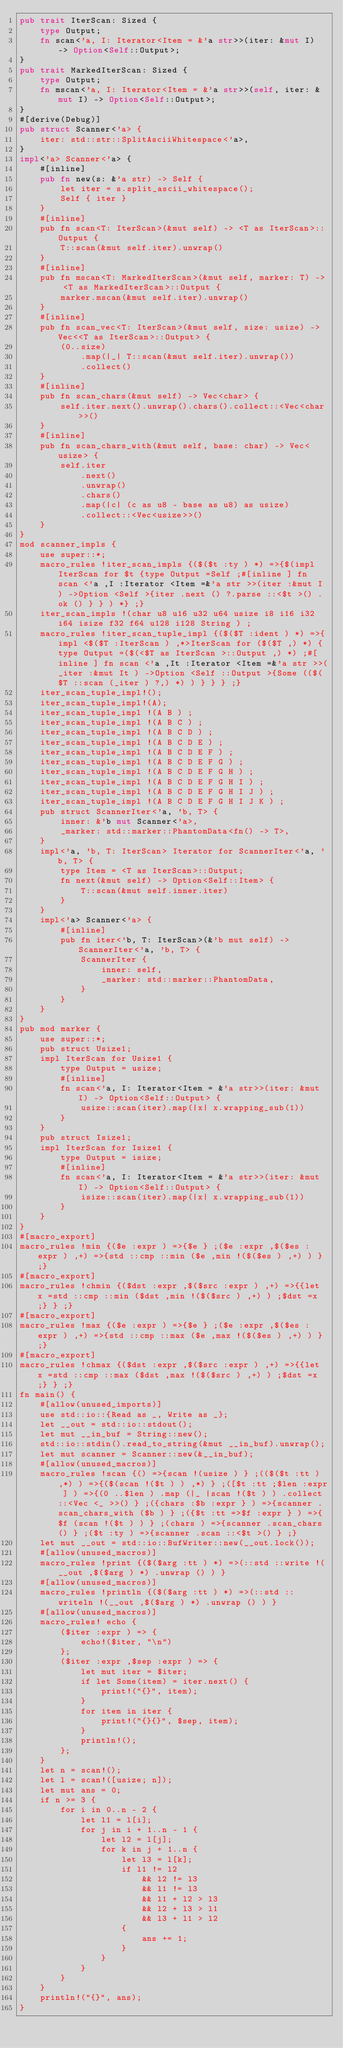Convert code to text. <code><loc_0><loc_0><loc_500><loc_500><_Rust_>pub trait IterScan: Sized {
    type Output;
    fn scan<'a, I: Iterator<Item = &'a str>>(iter: &mut I) -> Option<Self::Output>;
}
pub trait MarkedIterScan: Sized {
    type Output;
    fn mscan<'a, I: Iterator<Item = &'a str>>(self, iter: &mut I) -> Option<Self::Output>;
}
#[derive(Debug)]
pub struct Scanner<'a> {
    iter: std::str::SplitAsciiWhitespace<'a>,
}
impl<'a> Scanner<'a> {
    #[inline]
    pub fn new(s: &'a str) -> Self {
        let iter = s.split_ascii_whitespace();
        Self { iter }
    }
    #[inline]
    pub fn scan<T: IterScan>(&mut self) -> <T as IterScan>::Output {
        T::scan(&mut self.iter).unwrap()
    }
    #[inline]
    pub fn mscan<T: MarkedIterScan>(&mut self, marker: T) -> <T as MarkedIterScan>::Output {
        marker.mscan(&mut self.iter).unwrap()
    }
    #[inline]
    pub fn scan_vec<T: IterScan>(&mut self, size: usize) -> Vec<<T as IterScan>::Output> {
        (0..size)
            .map(|_| T::scan(&mut self.iter).unwrap())
            .collect()
    }
    #[inline]
    pub fn scan_chars(&mut self) -> Vec<char> {
        self.iter.next().unwrap().chars().collect::<Vec<char>>()
    }
    #[inline]
    pub fn scan_chars_with(&mut self, base: char) -> Vec<usize> {
        self.iter
            .next()
            .unwrap()
            .chars()
            .map(|c| (c as u8 - base as u8) as usize)
            .collect::<Vec<usize>>()
    }
}
mod scanner_impls {
    use super::*;
    macro_rules !iter_scan_impls {($($t :ty ) *) =>{$(impl IterScan for $t {type Output =Self ;#[inline ] fn scan <'a ,I :Iterator <Item =&'a str >>(iter :&mut I ) ->Option <Self >{iter .next () ?.parse ::<$t >() .ok () } } ) *} ;}
    iter_scan_impls !(char u8 u16 u32 u64 usize i8 i16 i32 i64 isize f32 f64 u128 i128 String ) ;
    macro_rules !iter_scan_tuple_impl {($($T :ident ) *) =>{impl <$($T :IterScan ) ,*>IterScan for ($($T ,) *) {type Output =($(<$T as IterScan >::Output ,) *) ;#[inline ] fn scan <'a ,It :Iterator <Item =&'a str >>(_iter :&mut It ) ->Option <Self ::Output >{Some (($($T ::scan (_iter ) ?,) *) ) } } } ;}
    iter_scan_tuple_impl!();
    iter_scan_tuple_impl!(A);
    iter_scan_tuple_impl !(A B ) ;
    iter_scan_tuple_impl !(A B C ) ;
    iter_scan_tuple_impl !(A B C D ) ;
    iter_scan_tuple_impl !(A B C D E ) ;
    iter_scan_tuple_impl !(A B C D E F ) ;
    iter_scan_tuple_impl !(A B C D E F G ) ;
    iter_scan_tuple_impl !(A B C D E F G H ) ;
    iter_scan_tuple_impl !(A B C D E F G H I ) ;
    iter_scan_tuple_impl !(A B C D E F G H I J ) ;
    iter_scan_tuple_impl !(A B C D E F G H I J K ) ;
    pub struct ScannerIter<'a, 'b, T> {
        inner: &'b mut Scanner<'a>,
        _marker: std::marker::PhantomData<fn() -> T>,
    }
    impl<'a, 'b, T: IterScan> Iterator for ScannerIter<'a, 'b, T> {
        type Item = <T as IterScan>::Output;
        fn next(&mut self) -> Option<Self::Item> {
            T::scan(&mut self.inner.iter)
        }
    }
    impl<'a> Scanner<'a> {
        #[inline]
        pub fn iter<'b, T: IterScan>(&'b mut self) -> ScannerIter<'a, 'b, T> {
            ScannerIter {
                inner: self,
                _marker: std::marker::PhantomData,
            }
        }
    }
}
pub mod marker {
    use super::*;
    pub struct Usize1;
    impl IterScan for Usize1 {
        type Output = usize;
        #[inline]
        fn scan<'a, I: Iterator<Item = &'a str>>(iter: &mut I) -> Option<Self::Output> {
            usize::scan(iter).map(|x| x.wrapping_sub(1))
        }
    }
    pub struct Isize1;
    impl IterScan for Isize1 {
        type Output = isize;
        #[inline]
        fn scan<'a, I: Iterator<Item = &'a str>>(iter: &mut I) -> Option<Self::Output> {
            isize::scan(iter).map(|x| x.wrapping_sub(1))
        }
    }
}
#[macro_export]
macro_rules !min {($e :expr ) =>{$e } ;($e :expr ,$($es :expr ) ,+) =>{std ::cmp ::min ($e ,min !($($es ) ,+) ) } ;}
#[macro_export]
macro_rules !chmin {($dst :expr ,$($src :expr ) ,+) =>{{let x =std ::cmp ::min ($dst ,min !($($src ) ,+) ) ;$dst =x ;} } ;}
#[macro_export]
macro_rules !max {($e :expr ) =>{$e } ;($e :expr ,$($es :expr ) ,+) =>{std ::cmp ::max ($e ,max !($($es ) ,+) ) } ;}
#[macro_export]
macro_rules !chmax {($dst :expr ,$($src :expr ) ,+) =>{{let x =std ::cmp ::max ($dst ,max !($($src ) ,+) ) ;$dst =x ;} } ;}
fn main() {
    #[allow(unused_imports)]
    use std::io::{Read as _, Write as _};
    let __out = std::io::stdout();
    let mut __in_buf = String::new();
    std::io::stdin().read_to_string(&mut __in_buf).unwrap();
    let mut scanner = Scanner::new(&__in_buf);
    #[allow(unused_macros)]
    macro_rules !scan {() =>{scan !(usize ) } ;(($($t :tt ) ,*) ) =>{($(scan !($t ) ) ,*) } ;([$t :tt ;$len :expr ] ) =>{(0 ..$len ) .map (|_ |scan !($t ) ) .collect ::<Vec <_ >>() } ;({chars :$b :expr } ) =>{scanner .scan_chars_with ($b ) } ;({$t :tt =>$f :expr } ) =>{$f (scan !($t ) ) } ;(chars ) =>{scanner .scan_chars () } ;($t :ty ) =>{scanner .scan ::<$t >() } ;}
    let mut __out = std::io::BufWriter::new(__out.lock());
    #[allow(unused_macros)]
    macro_rules !print {($($arg :tt ) *) =>(::std ::write !(__out ,$($arg ) *) .unwrap () ) }
    #[allow(unused_macros)]
    macro_rules !println {($($arg :tt ) *) =>(::std ::writeln !(__out ,$($arg ) *) .unwrap () ) }
    #[allow(unused_macros)]
    macro_rules! echo {
        ($iter :expr ) => {
            echo!($iter, "\n")
        };
        ($iter :expr ,$sep :expr ) => {
            let mut iter = $iter;
            if let Some(item) = iter.next() {
                print!("{}", item);
            }
            for item in iter {
                print!("{}{}", $sep, item);
            }
            println!();
        };
    }
    let n = scan!();
    let l = scan!([usize; n]);
    let mut ans = 0;
    if n >= 3 {
        for i in 0..n - 2 {
            let l1 = l[i];
            for j in i + 1..n - 1 {
                let l2 = l[j];
                for k in j + 1..n {
                    let l3 = l[k];
                    if l1 != l2
                        && l2 != l3
                        && l1 != l3
                        && l1 + l2 > l3
                        && l2 + l3 > l1
                        && l3 + l1 > l2
                    {
                        ans += 1;
                    }
                }
            }
        }
    }
    println!("{}", ans);
}</code> 